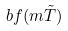<formula> <loc_0><loc_0><loc_500><loc_500>b f ( m \tilde { T } )</formula> 